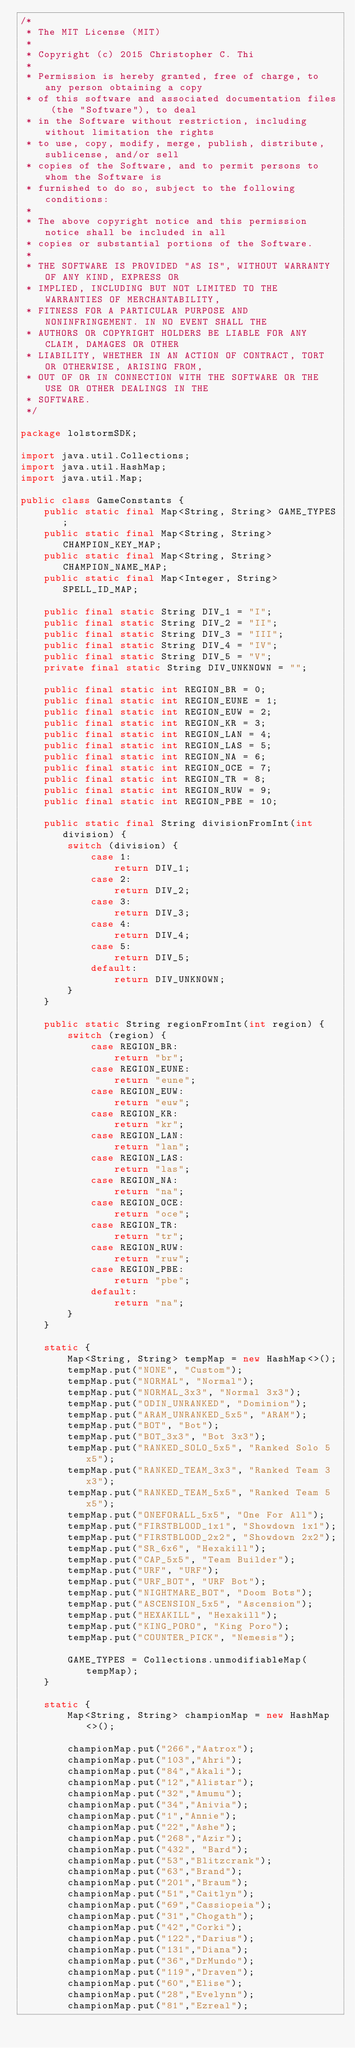<code> <loc_0><loc_0><loc_500><loc_500><_Java_>/*
 * The MIT License (MIT)
 *
 * Copyright (c) 2015 Christopher C. Thi
 *
 * Permission is hereby granted, free of charge, to any person obtaining a copy
 * of this software and associated documentation files (the "Software"), to deal
 * in the Software without restriction, including without limitation the rights
 * to use, copy, modify, merge, publish, distribute, sublicense, and/or sell
 * copies of the Software, and to permit persons to whom the Software is
 * furnished to do so, subject to the following conditions:
 *
 * The above copyright notice and this permission notice shall be included in all
 * copies or substantial portions of the Software.
 *
 * THE SOFTWARE IS PROVIDED "AS IS", WITHOUT WARRANTY OF ANY KIND, EXPRESS OR
 * IMPLIED, INCLUDING BUT NOT LIMITED TO THE WARRANTIES OF MERCHANTABILITY,
 * FITNESS FOR A PARTICULAR PURPOSE AND NONINFRINGEMENT. IN NO EVENT SHALL THE
 * AUTHORS OR COPYRIGHT HOLDERS BE LIABLE FOR ANY CLAIM, DAMAGES OR OTHER
 * LIABILITY, WHETHER IN AN ACTION OF CONTRACT, TORT OR OTHERWISE, ARISING FROM,
 * OUT OF OR IN CONNECTION WITH THE SOFTWARE OR THE USE OR OTHER DEALINGS IN THE
 * SOFTWARE.
 */

package lolstormSDK;

import java.util.Collections;
import java.util.HashMap;
import java.util.Map;

public class GameConstants {
    public static final Map<String, String> GAME_TYPES;
    public static final Map<String, String> CHAMPION_KEY_MAP;
    public static final Map<String, String> CHAMPION_NAME_MAP;
    public static final Map<Integer, String> SPELL_ID_MAP;

    public final static String DIV_1 = "I";
    public final static String DIV_2 = "II";
    public final static String DIV_3 = "III";
    public final static String DIV_4 = "IV";
    public final static String DIV_5 = "V";
    private final static String DIV_UNKNOWN = "";

    public final static int REGION_BR = 0;
    public final static int REGION_EUNE = 1;
    public final static int REGION_EUW = 2;
    public final static int REGION_KR = 3;
    public final static int REGION_LAN = 4;
    public final static int REGION_LAS = 5;
    public final static int REGION_NA = 6;
    public final static int REGION_OCE = 7;
    public final static int REGION_TR = 8;
    public final static int REGION_RUW = 9;
    public final static int REGION_PBE = 10;

    public static final String divisionFromInt(int division) {
        switch (division) {
            case 1:
                return DIV_1;
            case 2:
                return DIV_2;
            case 3:
                return DIV_3;
            case 4:
                return DIV_4;
            case 5:
                return DIV_5;
            default:
                return DIV_UNKNOWN;
        }
    }

    public static String regionFromInt(int region) {
        switch (region) {
            case REGION_BR:
                return "br";
            case REGION_EUNE:
                return "eune";
            case REGION_EUW:
                return "euw";
            case REGION_KR:
                return "kr";
            case REGION_LAN:
                return "lan";
            case REGION_LAS:
                return "las";
            case REGION_NA:
                return "na";
            case REGION_OCE:
                return "oce";
            case REGION_TR:
                return "tr";
            case REGION_RUW:
                return "ruw";
            case REGION_PBE:
                return "pbe";
            default:
                return "na";
        }
    }

    static {
        Map<String, String> tempMap = new HashMap<>();
        tempMap.put("NONE", "Custom");
        tempMap.put("NORMAL", "Normal");
        tempMap.put("NORMAL_3x3", "Normal 3x3");
        tempMap.put("ODIN_UNRANKED", "Dominion");
        tempMap.put("ARAM_UNRANKED_5x5", "ARAM");
        tempMap.put("BOT", "Bot");
        tempMap.put("BOT_3x3", "Bot 3x3");
        tempMap.put("RANKED_SOLO_5x5", "Ranked Solo 5x5");
        tempMap.put("RANKED_TEAM_3x3", "Ranked Team 3x3");
        tempMap.put("RANKED_TEAM_5x5", "Ranked Team 5x5");
        tempMap.put("ONEFORALL_5x5", "One For All");
        tempMap.put("FIRSTBLOOD_1x1", "Showdown 1x1");
        tempMap.put("FIRSTBLOOD_2x2", "Showdown 2x2");
        tempMap.put("SR_6x6", "Hexakill");
        tempMap.put("CAP_5x5", "Team Builder");
        tempMap.put("URF", "URF");
        tempMap.put("URF_BOT", "URF Bot");
        tempMap.put("NIGHTMARE_BOT", "Doom Bots");
        tempMap.put("ASCENSION_5x5", "Ascension");
        tempMap.put("HEXAKILL", "Hexakill");
        tempMap.put("KING_PORO", "King Poro");
        tempMap.put("COUNTER_PICK", "Nemesis");

        GAME_TYPES = Collections.unmodifiableMap(tempMap);
    }

    static {
        Map<String, String> championMap = new HashMap<>();

        championMap.put("266","Aatrox");
        championMap.put("103","Ahri");
        championMap.put("84","Akali");
        championMap.put("12","Alistar");
        championMap.put("32","Amumu");
        championMap.put("34","Anivia");
        championMap.put("1","Annie");
        championMap.put("22","Ashe");
        championMap.put("268","Azir");
        championMap.put("432", "Bard");
        championMap.put("53","Blitzcrank");
        championMap.put("63","Brand");
        championMap.put("201","Braum");
        championMap.put("51","Caitlyn");
        championMap.put("69","Cassiopeia");
        championMap.put("31","Chogath");
        championMap.put("42","Corki");
        championMap.put("122","Darius");
        championMap.put("131","Diana");
        championMap.put("36","DrMundo");
        championMap.put("119","Draven");
        championMap.put("60","Elise");
        championMap.put("28","Evelynn");
        championMap.put("81","Ezreal");</code> 